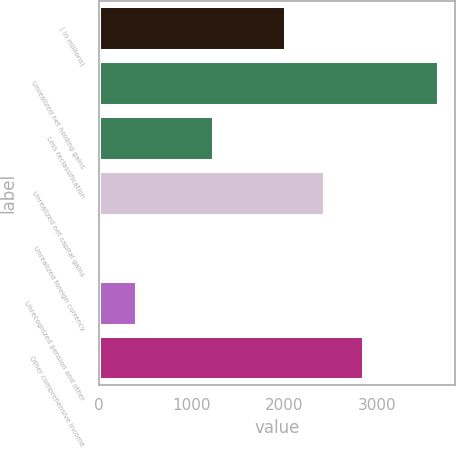<chart> <loc_0><loc_0><loc_500><loc_500><bar_chart><fcel>( in millions)<fcel>Unrealized net holding gains<fcel>Less reclassification<fcel>Unrealized net capital gains<fcel>Unrealized foreign currency<fcel>Unrecognized pension and other<fcel>Other comprehensive income<nl><fcel>2008<fcel>3660<fcel>1228<fcel>2432<fcel>40<fcel>402<fcel>2851<nl></chart> 